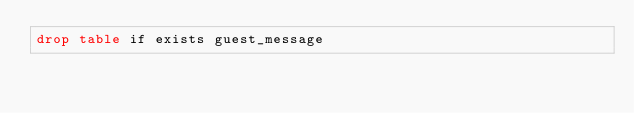Convert code to text. <code><loc_0><loc_0><loc_500><loc_500><_SQL_>drop table if exists guest_message
</code> 